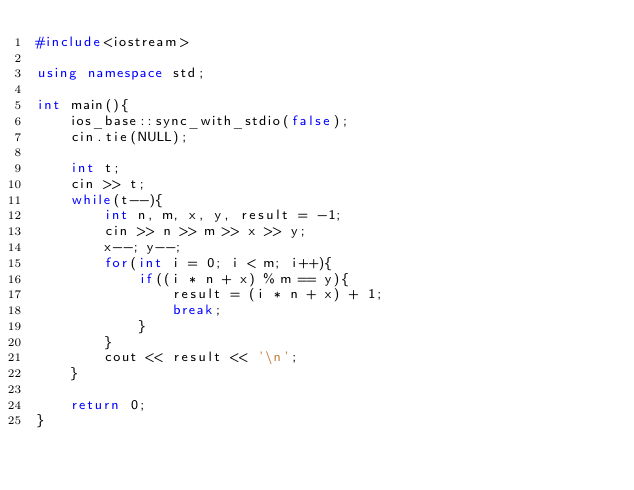Convert code to text. <code><loc_0><loc_0><loc_500><loc_500><_C++_>#include<iostream>

using namespace std;

int main(){
    ios_base::sync_with_stdio(false);
    cin.tie(NULL);

    int t;
    cin >> t;
    while(t--){
        int n, m, x, y, result = -1;
        cin >> n >> m >> x >> y;
        x--; y--;
        for(int i = 0; i < m; i++){
            if((i * n + x) % m == y){
                result = (i * n + x) + 1;
                break;
            }
        }
        cout << result << '\n';
    }

    return 0;
}</code> 